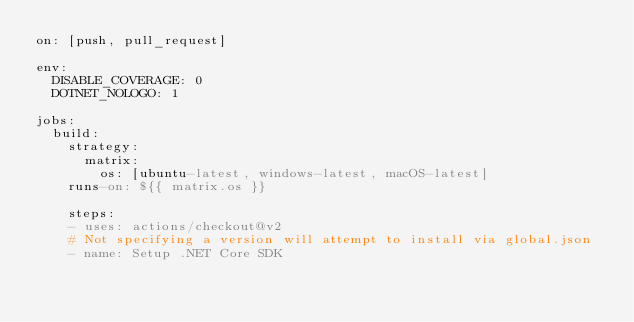Convert code to text. <code><loc_0><loc_0><loc_500><loc_500><_YAML_>on: [push, pull_request]

env:
  DISABLE_COVERAGE: 0
  DOTNET_NOLOGO: 1

jobs:
  build:
    strategy:
      matrix:
        os: [ubuntu-latest, windows-latest, macOS-latest]
    runs-on: ${{ matrix.os }}

    steps:
    - uses: actions/checkout@v2
    # Not specifying a version will attempt to install via global.json
    - name: Setup .NET Core SDK</code> 